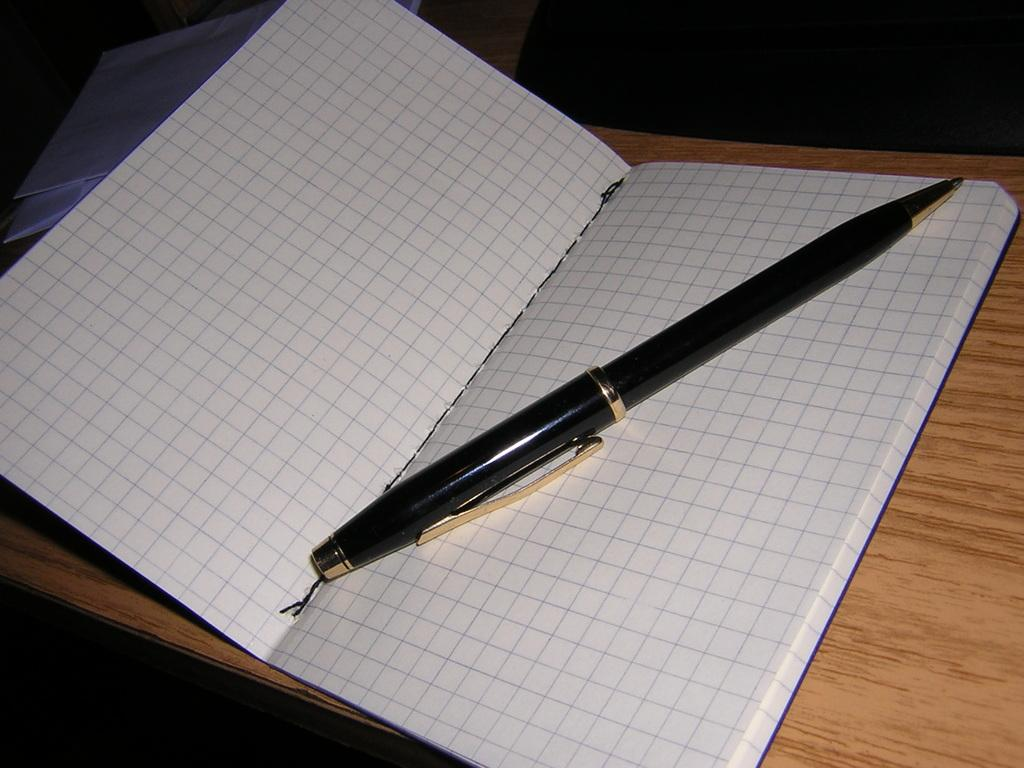What is placed on the book in the image? There is a pen on the book in the image. What is the book resting on? The book is on a wooden surface. Can you describe the two white objects in the image? There are two white color objects at the top of the image. What historical event is depicted in the image? There is no historical event depicted in the image; it features a pen on a book on a wooden surface and two white objects. Where is the dock located in the image? There is no dock present in the image. 